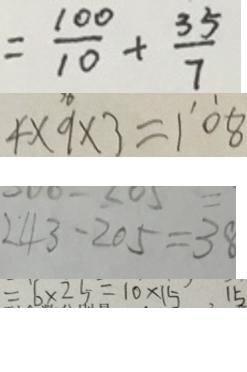Convert formula to latex. <formula><loc_0><loc_0><loc_500><loc_500>= \frac { 1 0 0 } { 1 0 } + \frac { 3 5 } { 7 } 
 4 \times 9 \times 3 = \dot { 1 } \dot { 0 } 8 
 2 4 3 - 2 0 5 = 3 8 
 = 6 \times 2 5 = 1 0 \times 1 5 . 1 5</formula> 